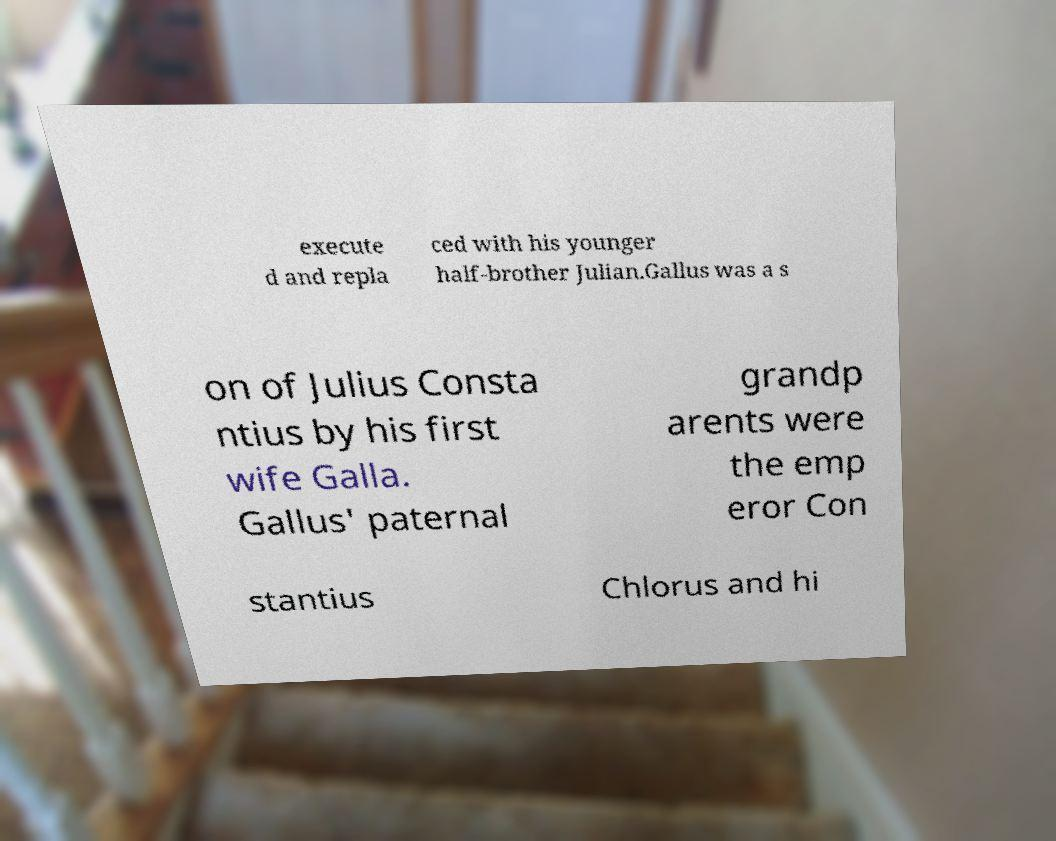Please read and relay the text visible in this image. What does it say? execute d and repla ced with his younger half-brother Julian.Gallus was a s on of Julius Consta ntius by his first wife Galla. Gallus' paternal grandp arents were the emp eror Con stantius Chlorus and hi 